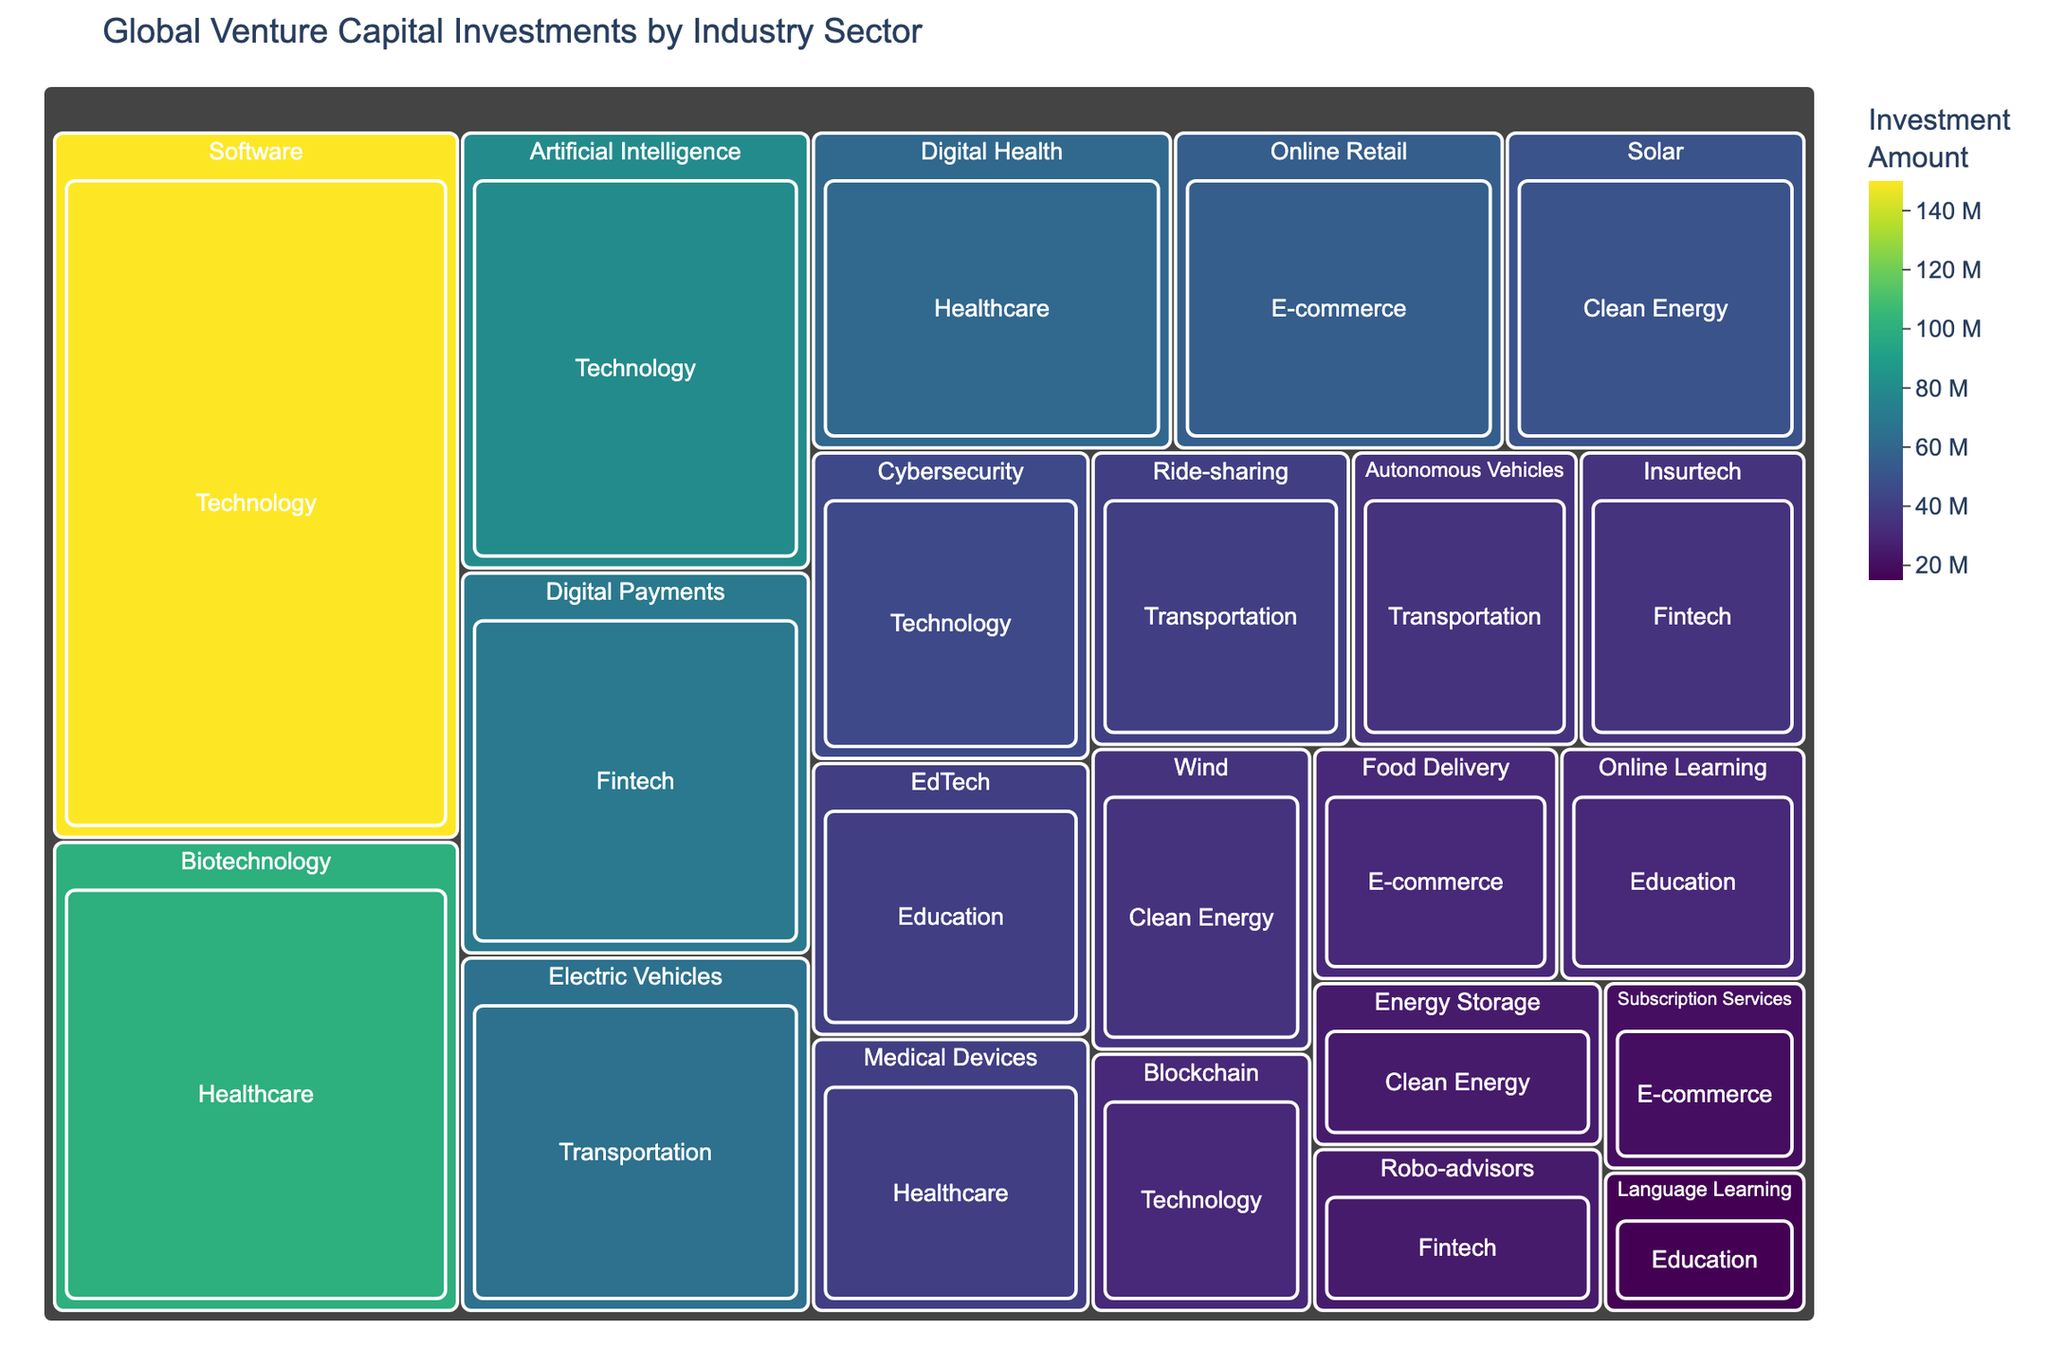Which industry sector has the highest total investment? By looking at the size and value of the boxes in the treemap, we can observe that the 'Technology' sector dominates the chart with the highest total investment, particularly driven by high investments in Software and Artificial Intelligence.
Answer: Technology How much investment did the 'Digital Health' industry sector receive? Locate the 'Digital Health' box within the 'Healthcare' sector section of the treemap. The value inside the box indicates the amount of investment, which is $60 million.
Answer: $60 million Which sector has a higher investment: 'Fintech' or 'Healthcare'? By comparing the sizes and values of the 'Fintech' and 'Healthcare' boxes, we can see that 'Healthcare' has higher total investments. 'Healthcare' shows $100M (Biotechnology), $60M (Digital Health), and $40M (Medical Devices), totaling $200M compared to 'Fintech' with $70M (Digital Payments), $35M (Insurtech), and $25M (Robo-advisors), totaling $130M.
Answer: Healthcare What is the combined investment for the 'Transportation' sector? Add up the investments from the 'Transportation' sector: $65M (Electric Vehicles), $40M (Ride-sharing), and $35M (Autonomous Vehicles). The total is $65M + $40M + $35M = $140M.
Answer: $140 million Which industry sector received the least investment overall? The smallest boxes and the values within indicate that 'Education' sectors received the least investment with $40M for EdTech, $30M for Online Learning, and $15M for Language Learning, totaling $85M.
Answer: Education Compare the investment amounts between 'Biotechnology' and 'Solar'. Which one received more investment? Compare the boxes for 'Biotechnology' in the 'Healthcare' sector and 'Solar' in the 'Clean Energy' sector. 'Biotechnology' received $100M, which is more than 'Solar' which received $50M.
Answer: Biotechnology What percentage of 'Technology' sector's total investment was directed towards 'Blockchain'? The 'Technology' sector has investments of $150M (Software), $80M (Artificial Intelligence), $45M (Cybersecurity), and $30M (Blockchain), totaling $305M. The percentage directed towards 'Blockchain' is (30/305) * 100 ≈ 9.84%.
Answer: 9.84% Which sector within 'Clean Energy' has the most substantial investment? By comparing the boxes within 'Clean Energy,' the 'Solar' sector has the highest investment amount of $50 million.
Answer: Solar How does the investment in 'Ride-sharing' within 'Transportation' compare to 'Insurtech' within 'Fintech'? Locate both 'Ride-sharing' and 'Insurtech' in their respective sectors. 'Ride-sharing' received $40 million, while 'Insurtech' received $35 million. 'Ride-sharing' has a higher investment.
Answer: Ride-sharing What's the total investment across all sectors? Sum up the investments from all the sectors: Technology ($305M), Fintech ($130M), Healthcare ($200M), E-commerce ($105M), Clean Energy ($110M), Education ($85M), Transportation ($140M). The total is $305M + $130M + $200M + $105M + $110M + $85M + $140M = $1075M.
Answer: $1075 million 